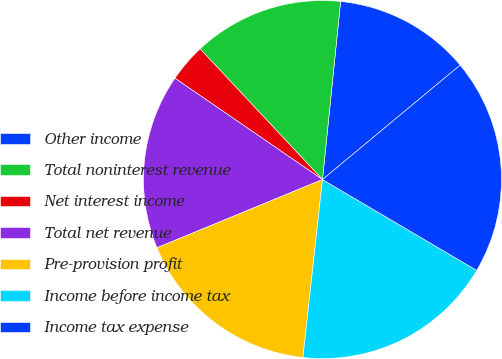<chart> <loc_0><loc_0><loc_500><loc_500><pie_chart><fcel>Other income<fcel>Total noninterest revenue<fcel>Net interest income<fcel>Total net revenue<fcel>Pre-provision profit<fcel>Income before income tax<fcel>Income tax expense<nl><fcel>12.35%<fcel>13.59%<fcel>3.45%<fcel>15.8%<fcel>17.04%<fcel>18.27%<fcel>19.51%<nl></chart> 